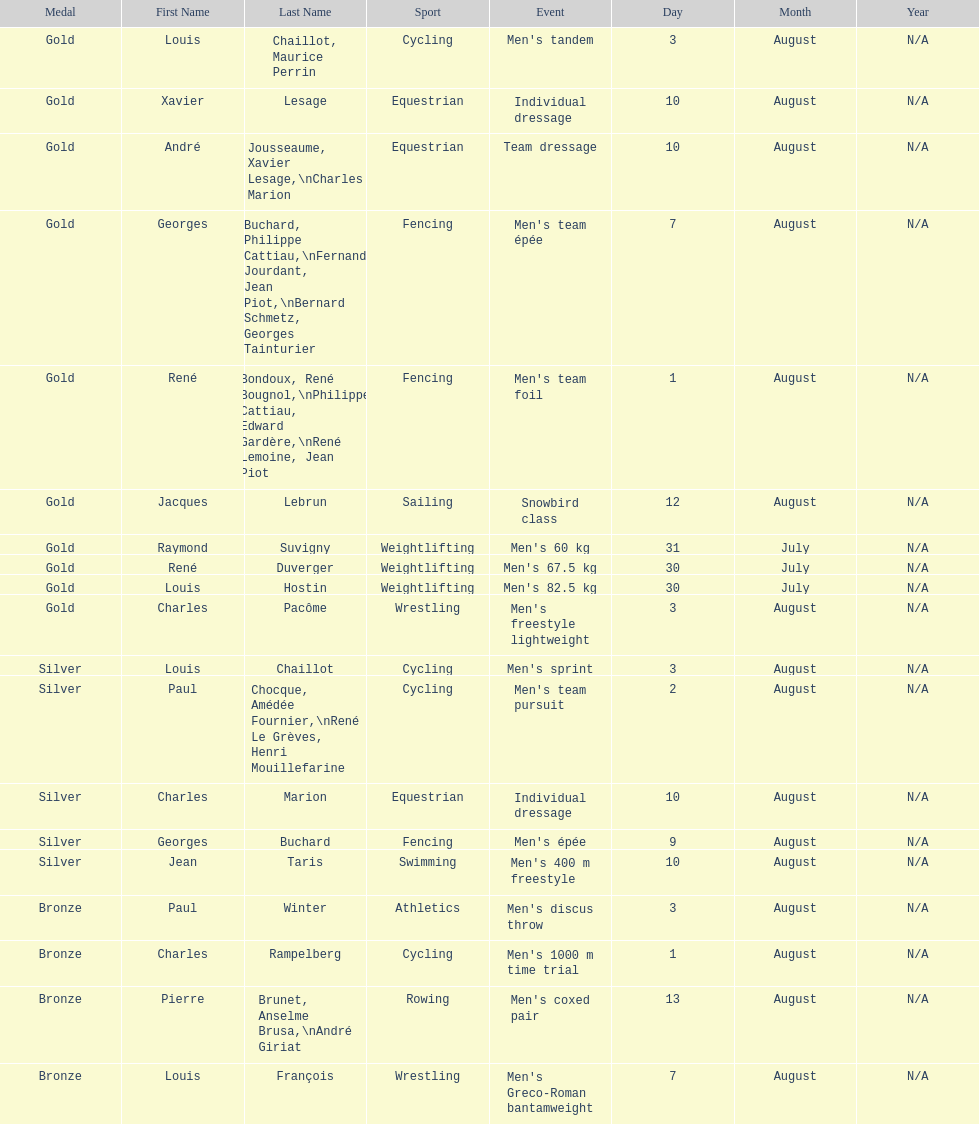What sport did louis challiot win the same medal as paul chocque in? Cycling. 